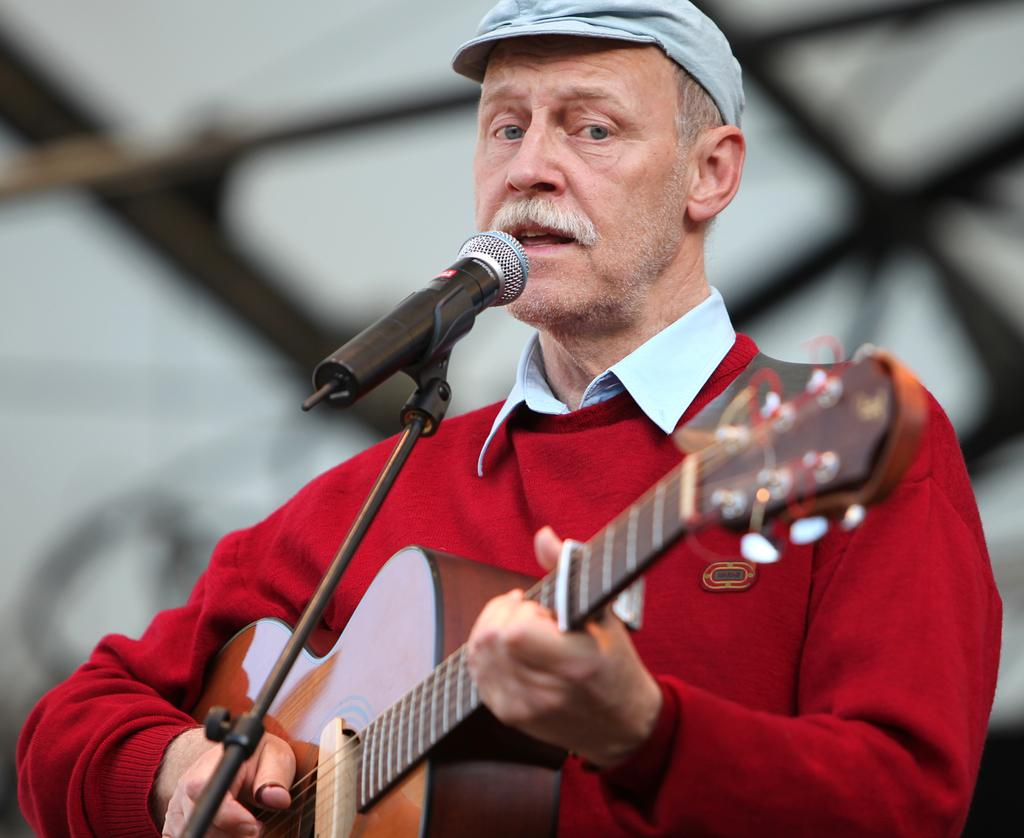What is the person holding in the image? The person is holding a guitar. What is the person doing with the guitar? The person is playing the guitar. What other activity is the person engaged in? The person is singing a song. What color is the jacket the person is wearing? The person is wearing a red color jacket. What type of headwear is the person wearing? The person is wearing a cap. What rule is being enforced by the person in the image? There is no indication of any rule being enforced in the image; the person is playing a guitar and singing a song. Can you describe the ground on which the person is standing in the image? The image does not provide any information about the ground on which the person is standing. 